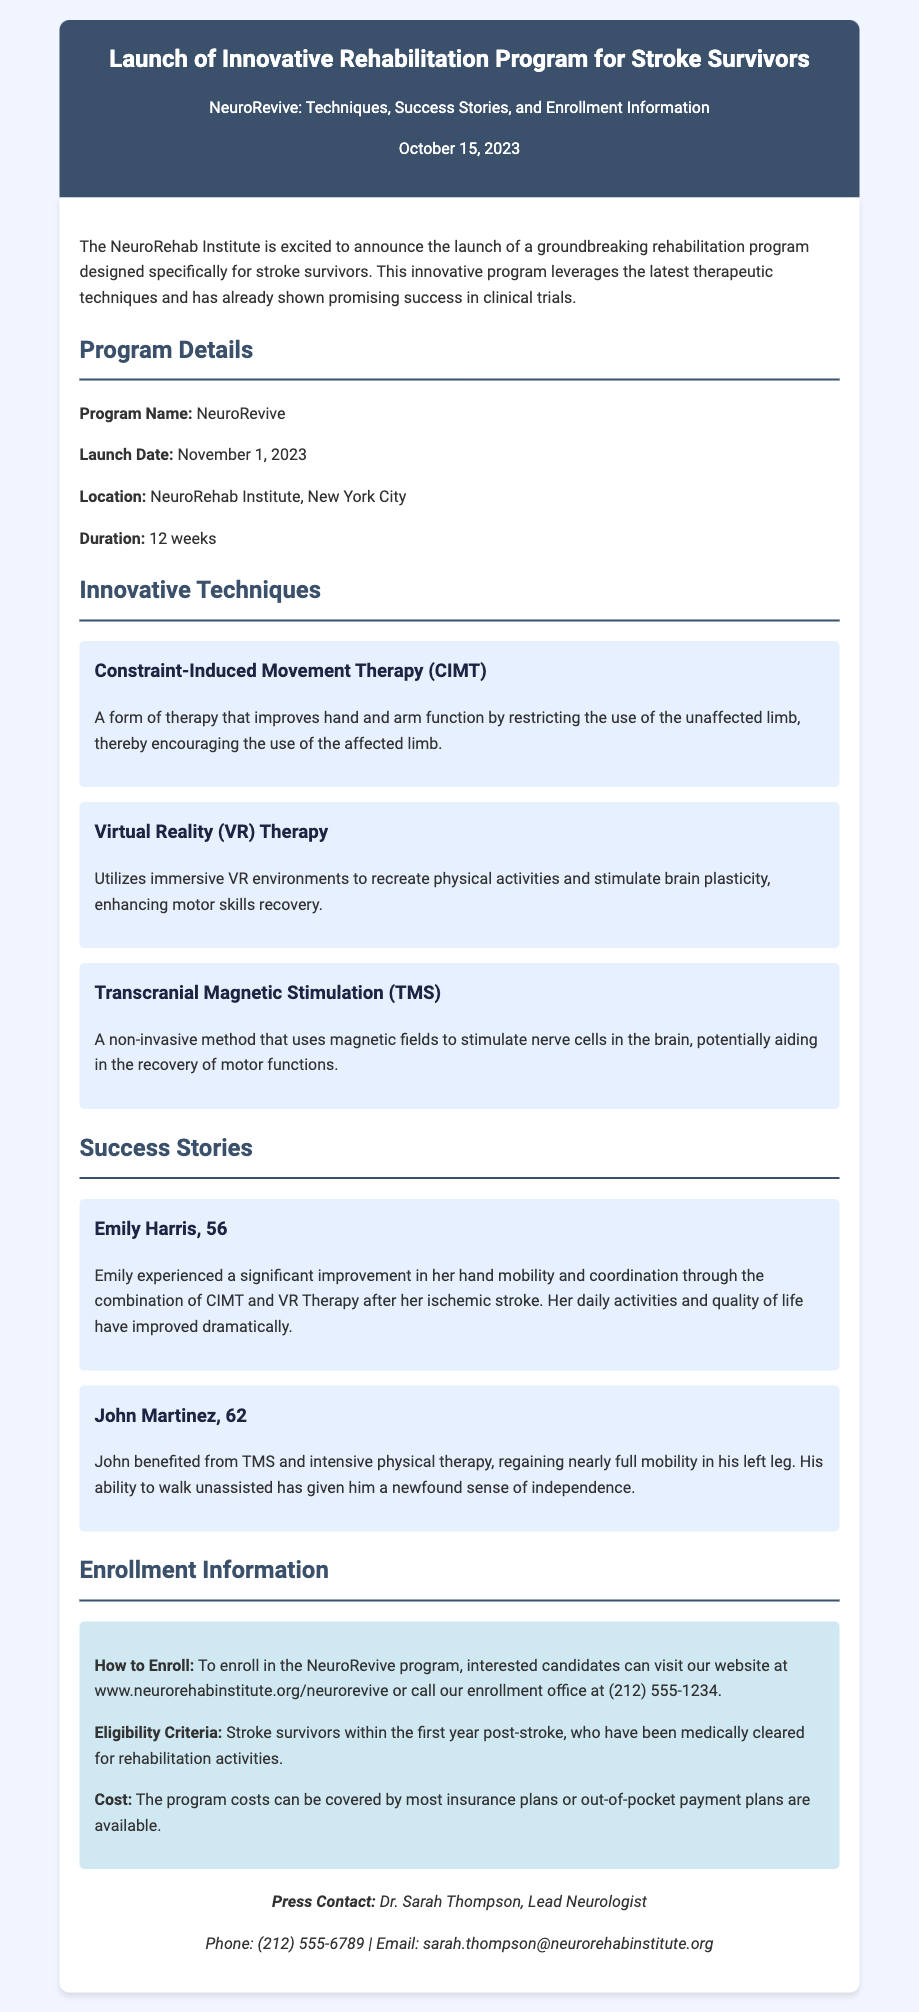What is the program name? The program name is clearly stated in the document, and it is NeuroRevive.
Answer: NeuroRevive When is the launch date of the program? The launch date is mentioned in the document under "Program Details," which is November 1, 2023.
Answer: November 1, 2023 What therapy technique encourages the use of the affected limb? The document describes Constraint-Induced Movement Therapy (CIMT) as the technique that encourages the use of the affected limb.
Answer: Constraint-Induced Movement Therapy (CIMT) Who is the lead neurologist for press contact? The document specifically mentions Dr. Sarah Thompson as the lead neurologist for press contact.
Answer: Dr. Sarah Thompson How long is the program duration? The document specifies the program duration as 12 weeks in the program details section.
Answer: 12 weeks What is the eligibility criteria for enrolling in the program? The eligibility criteria state that stroke survivors must be within the first year post-stroke and medically cleared for rehabilitation activities.
Answer: Stroke survivors within the first year post-stroke What success did Emily Harris experience? The document reports that Emily Harris experienced a significant improvement in her hand mobility and coordination through specific therapies.
Answer: Significant improvement in hand mobility and coordination What is the cost coverage for the program? The document notes that the program costs can be covered by most insurance plans, or out-of-pocket payment plans are available.
Answer: Covered by most insurance plans What location is the program based in? The location for the program is indicated in the document, which states it is at the NeuroRehab Institute, New York City.
Answer: NeuroRehab Institute, New York City 